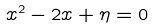<formula> <loc_0><loc_0><loc_500><loc_500>x ^ { 2 } - 2 x + \eta = 0</formula> 